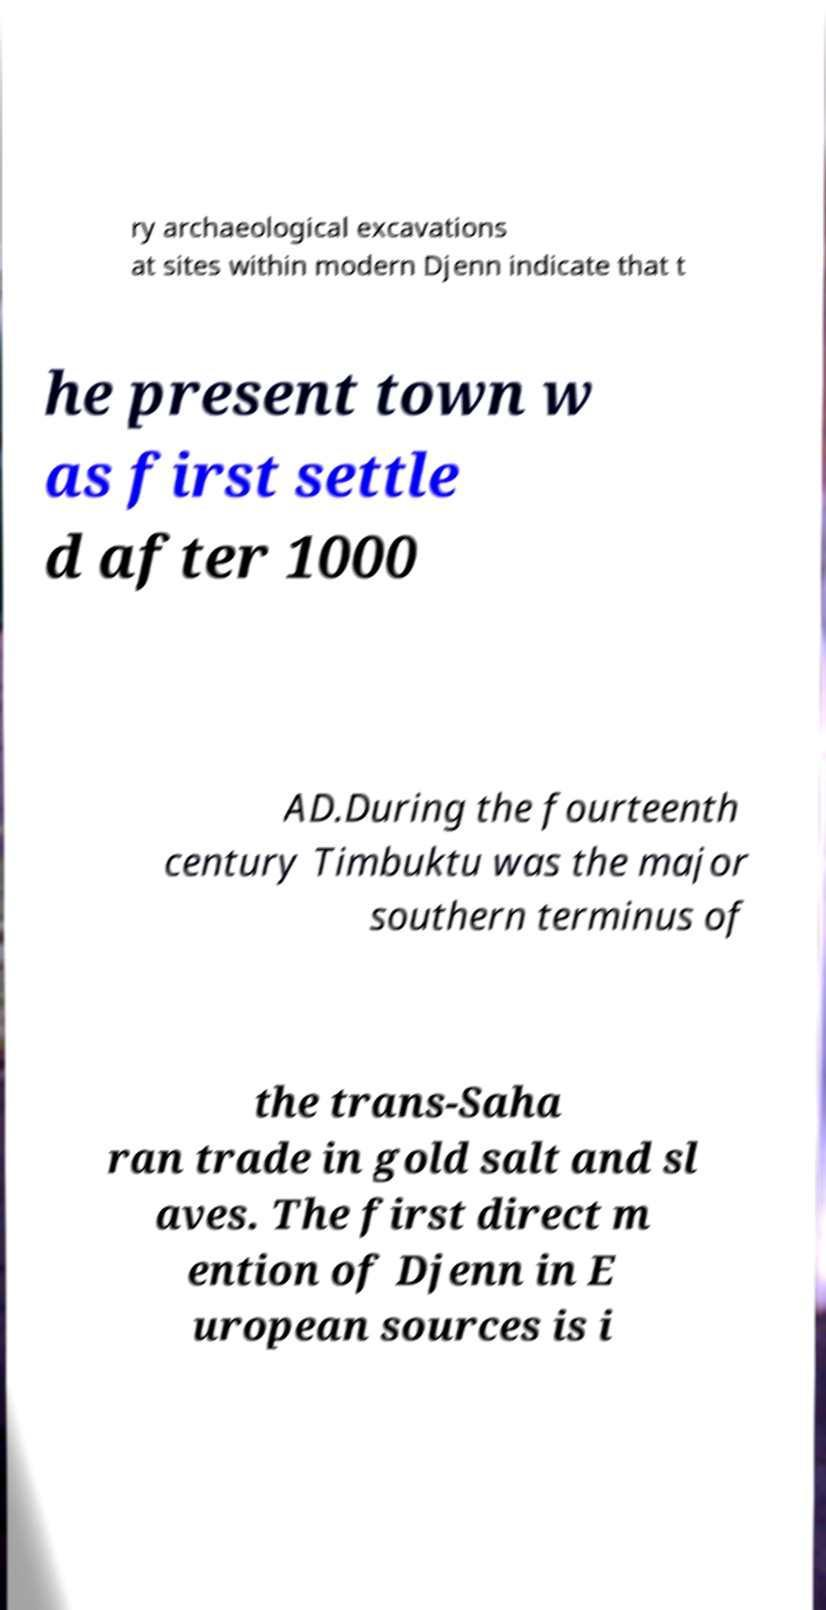There's text embedded in this image that I need extracted. Can you transcribe it verbatim? ry archaeological excavations at sites within modern Djenn indicate that t he present town w as first settle d after 1000 AD.During the fourteenth century Timbuktu was the major southern terminus of the trans-Saha ran trade in gold salt and sl aves. The first direct m ention of Djenn in E uropean sources is i 